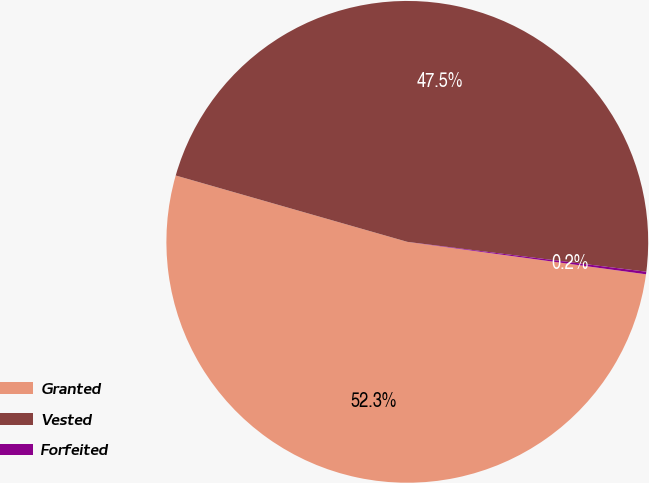<chart> <loc_0><loc_0><loc_500><loc_500><pie_chart><fcel>Granted<fcel>Vested<fcel>Forfeited<nl><fcel>52.29%<fcel>47.54%<fcel>0.17%<nl></chart> 